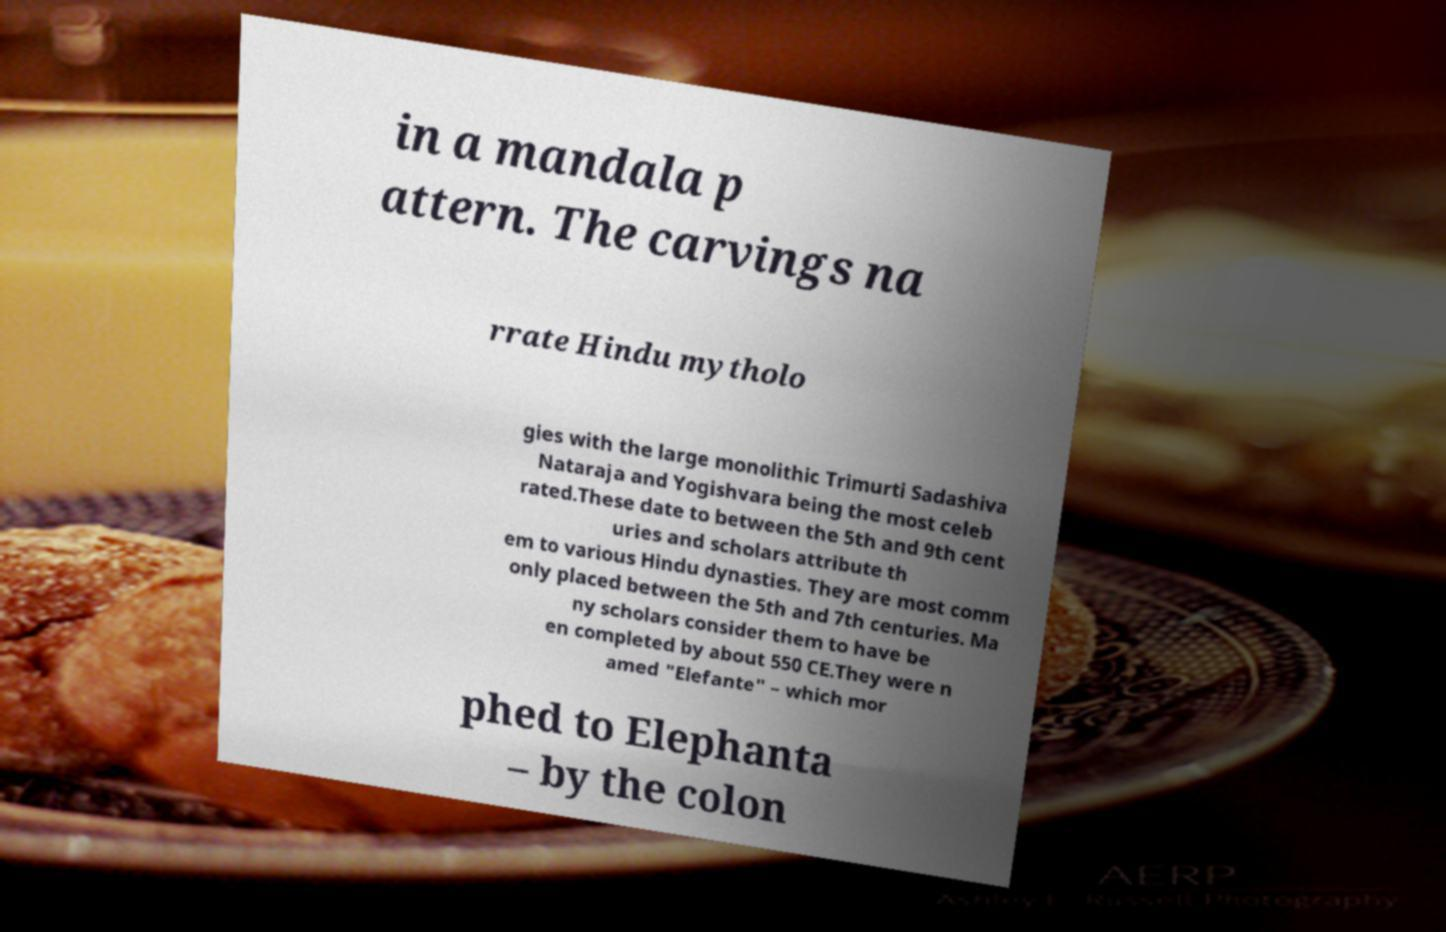For documentation purposes, I need the text within this image transcribed. Could you provide that? in a mandala p attern. The carvings na rrate Hindu mytholo gies with the large monolithic Trimurti Sadashiva Nataraja and Yogishvara being the most celeb rated.These date to between the 5th and 9th cent uries and scholars attribute th em to various Hindu dynasties. They are most comm only placed between the 5th and 7th centuries. Ma ny scholars consider them to have be en completed by about 550 CE.They were n amed "Elefante" – which mor phed to Elephanta – by the colon 